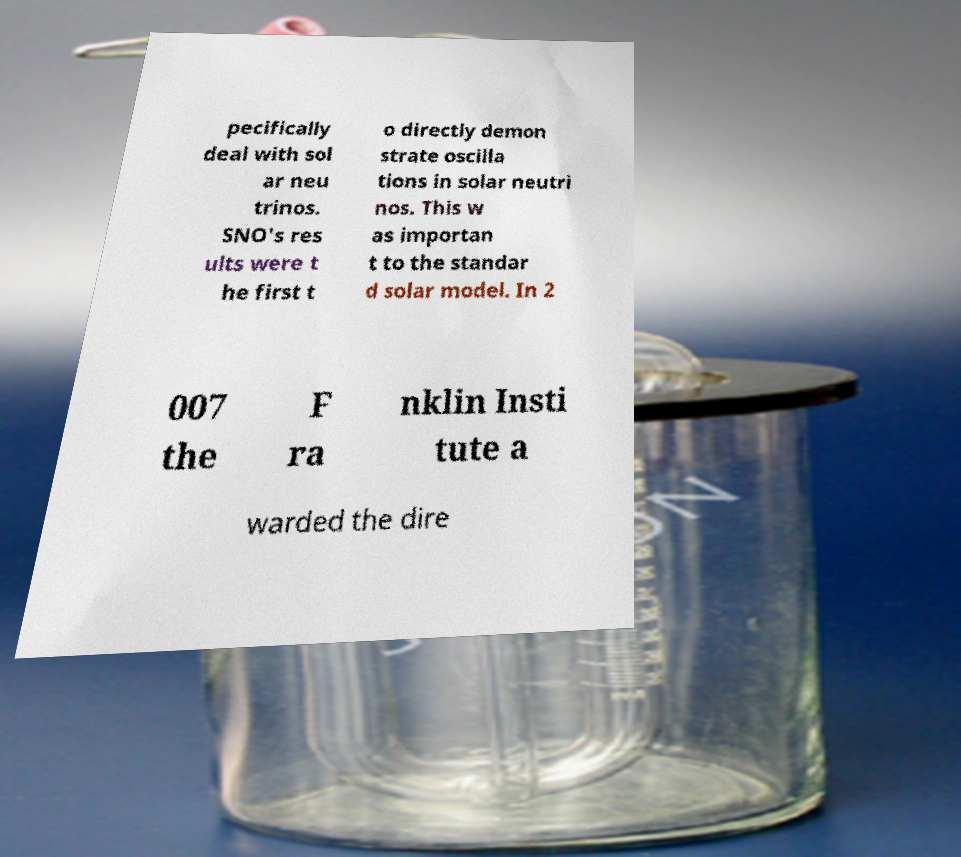Could you assist in decoding the text presented in this image and type it out clearly? pecifically deal with sol ar neu trinos. SNO's res ults were t he first t o directly demon strate oscilla tions in solar neutri nos. This w as importan t to the standar d solar model. In 2 007 the F ra nklin Insti tute a warded the dire 